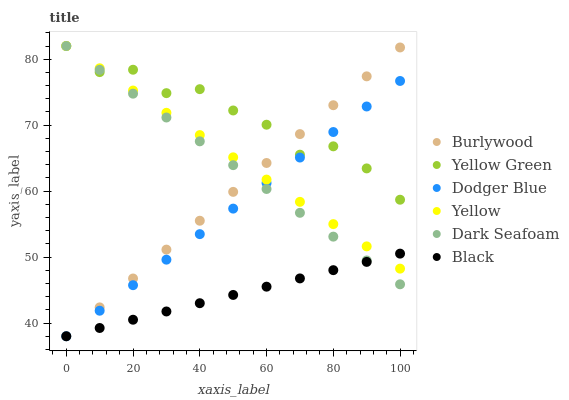Does Black have the minimum area under the curve?
Answer yes or no. Yes. Does Yellow Green have the maximum area under the curve?
Answer yes or no. Yes. Does Burlywood have the minimum area under the curve?
Answer yes or no. No. Does Burlywood have the maximum area under the curve?
Answer yes or no. No. Is Black the smoothest?
Answer yes or no. Yes. Is Yellow Green the roughest?
Answer yes or no. Yes. Is Burlywood the smoothest?
Answer yes or no. No. Is Burlywood the roughest?
Answer yes or no. No. Does Burlywood have the lowest value?
Answer yes or no. Yes. Does Yellow have the lowest value?
Answer yes or no. No. Does Dark Seafoam have the highest value?
Answer yes or no. Yes. Does Burlywood have the highest value?
Answer yes or no. No. Is Black less than Yellow Green?
Answer yes or no. Yes. Is Yellow Green greater than Black?
Answer yes or no. Yes. Does Burlywood intersect Yellow Green?
Answer yes or no. Yes. Is Burlywood less than Yellow Green?
Answer yes or no. No. Is Burlywood greater than Yellow Green?
Answer yes or no. No. Does Black intersect Yellow Green?
Answer yes or no. No. 